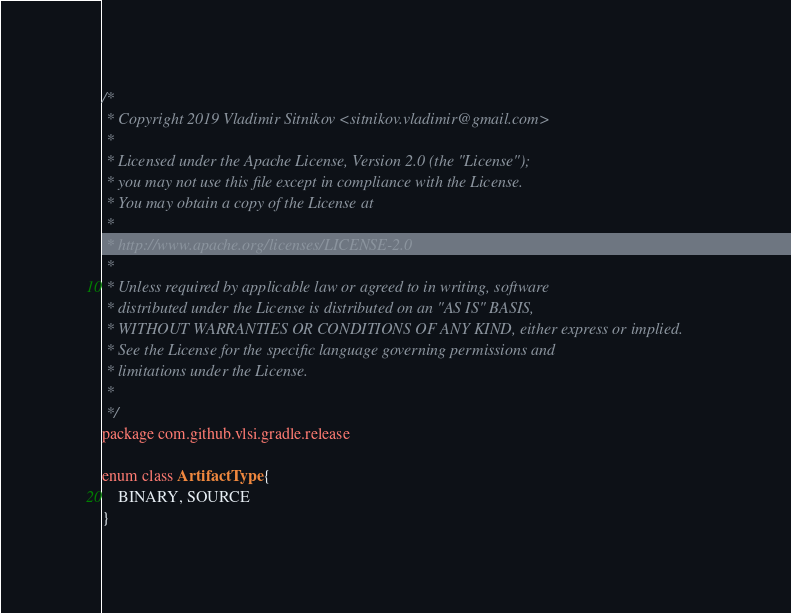<code> <loc_0><loc_0><loc_500><loc_500><_Kotlin_>/*
 * Copyright 2019 Vladimir Sitnikov <sitnikov.vladimir@gmail.com>
 *
 * Licensed under the Apache License, Version 2.0 (the "License");
 * you may not use this file except in compliance with the License.
 * You may obtain a copy of the License at
 *
 * http://www.apache.org/licenses/LICENSE-2.0
 *
 * Unless required by applicable law or agreed to in writing, software
 * distributed under the License is distributed on an "AS IS" BASIS,
 * WITHOUT WARRANTIES OR CONDITIONS OF ANY KIND, either express or implied.
 * See the License for the specific language governing permissions and
 * limitations under the License.
 *
 */
package com.github.vlsi.gradle.release

enum class ArtifactType {
    BINARY, SOURCE
}
</code> 